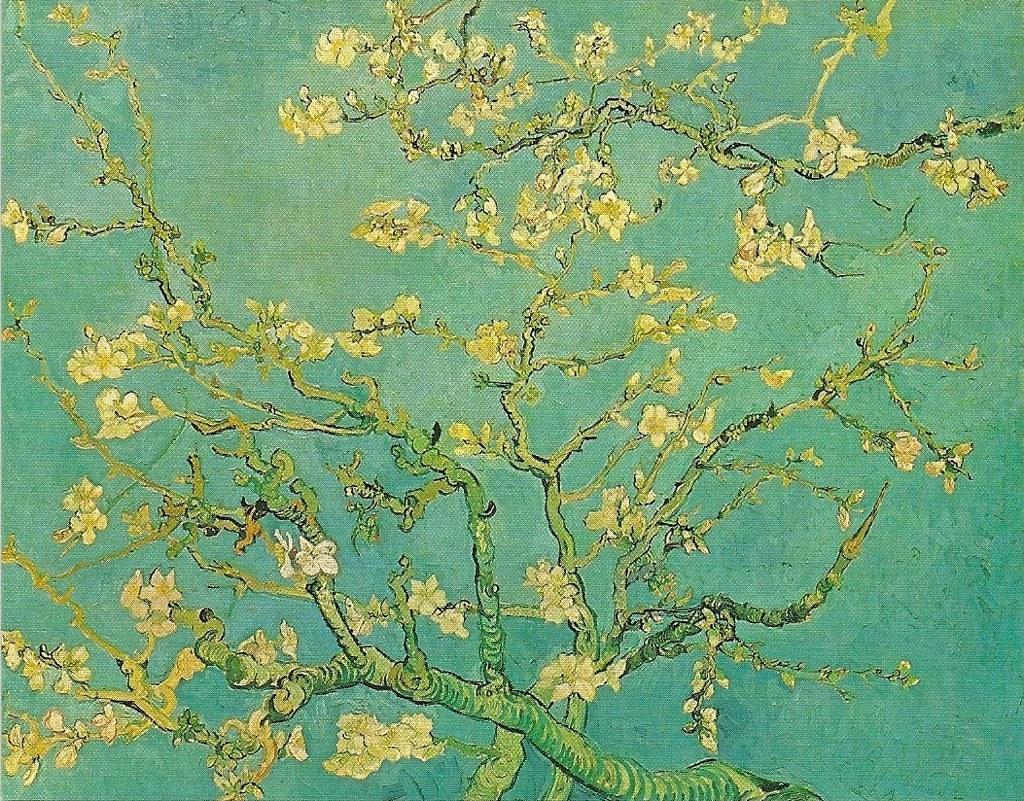In one or two sentences, can you explain what this image depicts? In the center of the image there is a painting, in which we can see branches with leaves. 